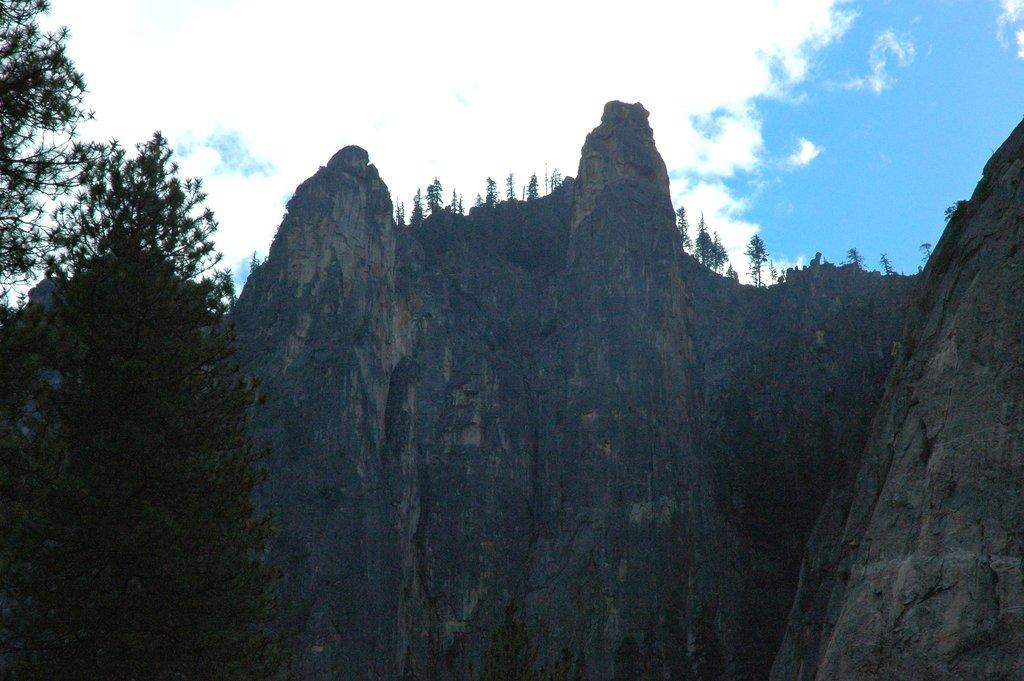What type of vegetation can be seen in the image? There are trees in the image. What geographical feature is present in the image? There is a mountain in the image. Where is the mountain located in the image? The mountain is at the bottom of the image. What can be seen in the background of the image? The sky is visible in the background of the image. What type of food is being served on the clock in the image? There is no clock or food present in the image. What knowledge can be gained from the trees in the image? The trees in the image do not convey any specific knowledge; they are simply a part of the landscape. 